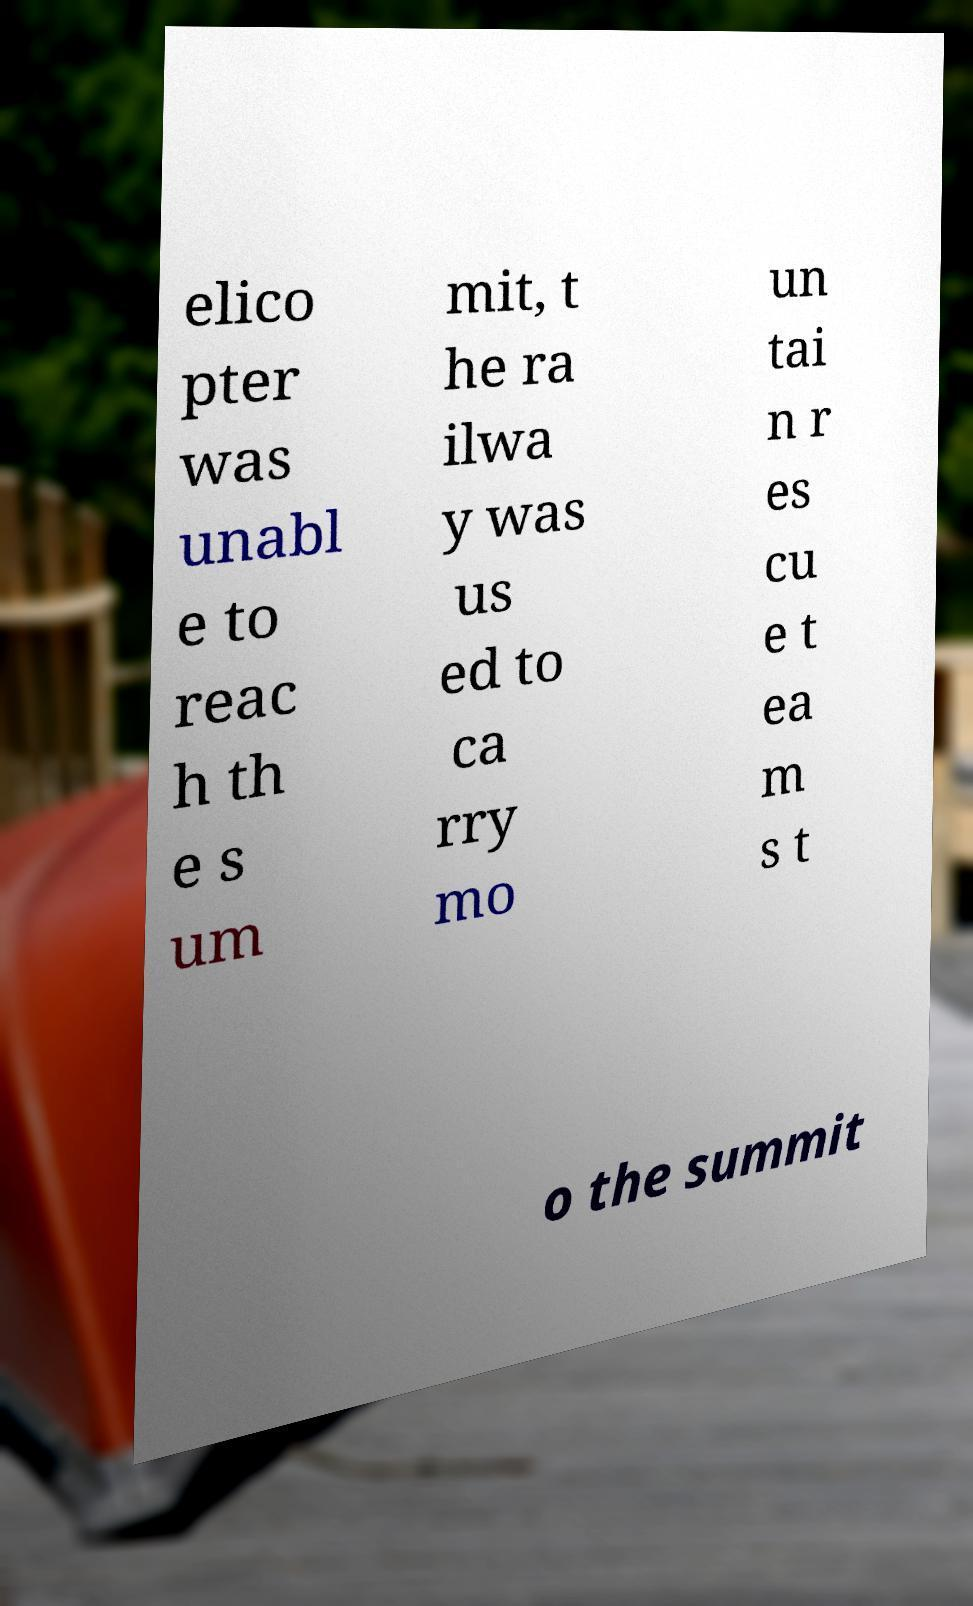Could you assist in decoding the text presented in this image and type it out clearly? elico pter was unabl e to reac h th e s um mit, t he ra ilwa y was us ed to ca rry mo un tai n r es cu e t ea m s t o the summit 